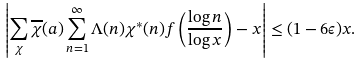<formula> <loc_0><loc_0><loc_500><loc_500>\left | \sum _ { \chi } \overline { \chi } ( a ) \sum _ { n = 1 } ^ { \infty } \Lambda ( n ) \chi ^ { * } ( n ) f \left ( \frac { \log { n } } { \log { x } } \right ) - x \right | \leq ( 1 - 6 \epsilon ) x .</formula> 